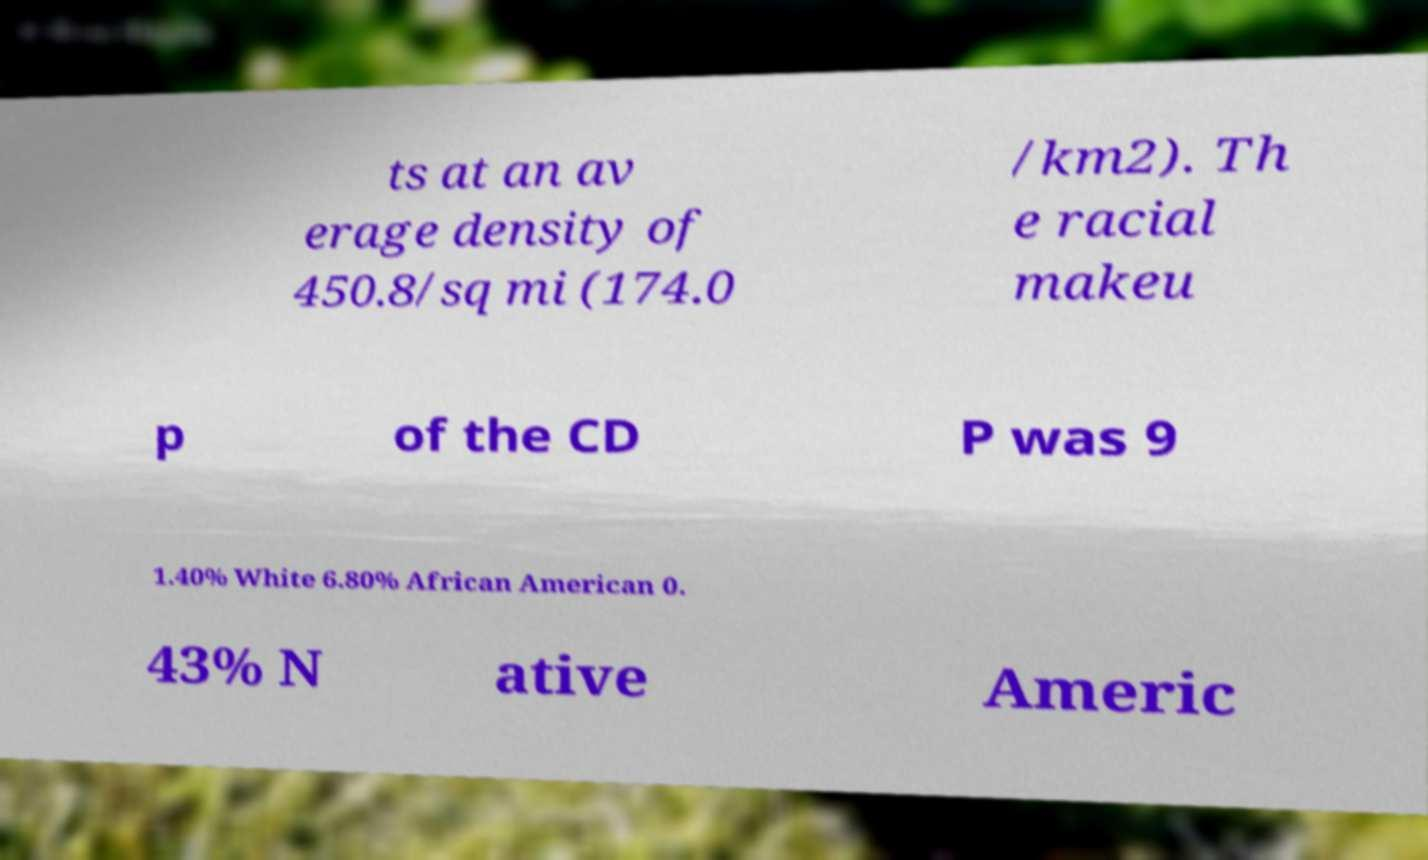What messages or text are displayed in this image? I need them in a readable, typed format. ts at an av erage density of 450.8/sq mi (174.0 /km2). Th e racial makeu p of the CD P was 9 1.40% White 6.80% African American 0. 43% N ative Americ 